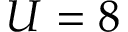<formula> <loc_0><loc_0><loc_500><loc_500>U = 8</formula> 